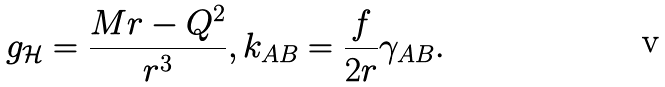<formula> <loc_0><loc_0><loc_500><loc_500>g _ { \mathcal { H } } = \frac { M r - Q ^ { 2 } } { r ^ { 3 } } , k _ { A B } = \frac { f } { 2 r } \gamma _ { A B } .</formula> 